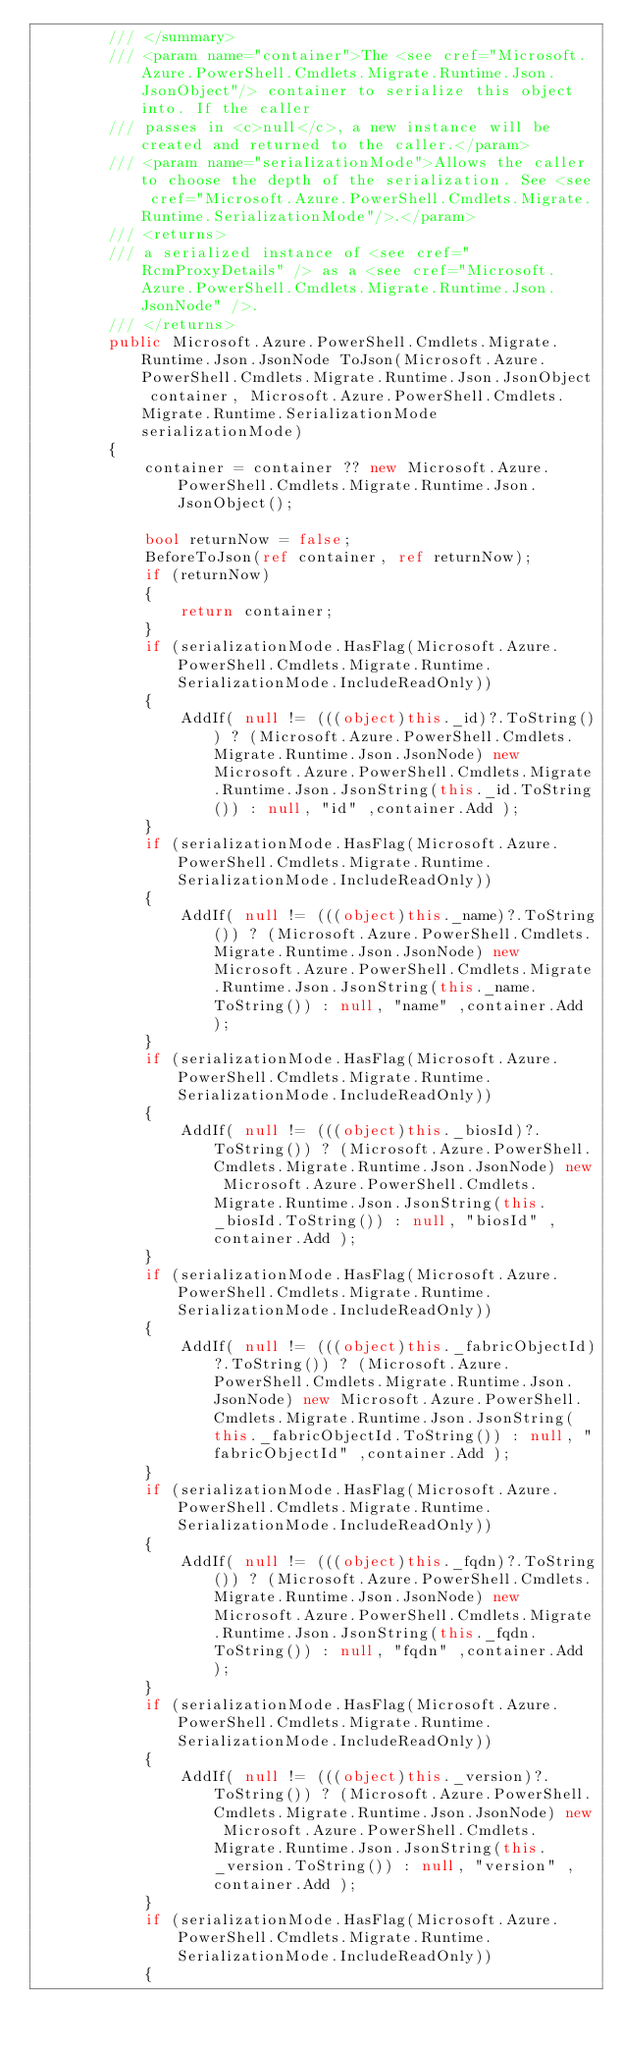<code> <loc_0><loc_0><loc_500><loc_500><_C#_>        /// </summary>
        /// <param name="container">The <see cref="Microsoft.Azure.PowerShell.Cmdlets.Migrate.Runtime.Json.JsonObject"/> container to serialize this object into. If the caller
        /// passes in <c>null</c>, a new instance will be created and returned to the caller.</param>
        /// <param name="serializationMode">Allows the caller to choose the depth of the serialization. See <see cref="Microsoft.Azure.PowerShell.Cmdlets.Migrate.Runtime.SerializationMode"/>.</param>
        /// <returns>
        /// a serialized instance of <see cref="RcmProxyDetails" /> as a <see cref="Microsoft.Azure.PowerShell.Cmdlets.Migrate.Runtime.Json.JsonNode" />.
        /// </returns>
        public Microsoft.Azure.PowerShell.Cmdlets.Migrate.Runtime.Json.JsonNode ToJson(Microsoft.Azure.PowerShell.Cmdlets.Migrate.Runtime.Json.JsonObject container, Microsoft.Azure.PowerShell.Cmdlets.Migrate.Runtime.SerializationMode serializationMode)
        {
            container = container ?? new Microsoft.Azure.PowerShell.Cmdlets.Migrate.Runtime.Json.JsonObject();

            bool returnNow = false;
            BeforeToJson(ref container, ref returnNow);
            if (returnNow)
            {
                return container;
            }
            if (serializationMode.HasFlag(Microsoft.Azure.PowerShell.Cmdlets.Migrate.Runtime.SerializationMode.IncludeReadOnly))
            {
                AddIf( null != (((object)this._id)?.ToString()) ? (Microsoft.Azure.PowerShell.Cmdlets.Migrate.Runtime.Json.JsonNode) new Microsoft.Azure.PowerShell.Cmdlets.Migrate.Runtime.Json.JsonString(this._id.ToString()) : null, "id" ,container.Add );
            }
            if (serializationMode.HasFlag(Microsoft.Azure.PowerShell.Cmdlets.Migrate.Runtime.SerializationMode.IncludeReadOnly))
            {
                AddIf( null != (((object)this._name)?.ToString()) ? (Microsoft.Azure.PowerShell.Cmdlets.Migrate.Runtime.Json.JsonNode) new Microsoft.Azure.PowerShell.Cmdlets.Migrate.Runtime.Json.JsonString(this._name.ToString()) : null, "name" ,container.Add );
            }
            if (serializationMode.HasFlag(Microsoft.Azure.PowerShell.Cmdlets.Migrate.Runtime.SerializationMode.IncludeReadOnly))
            {
                AddIf( null != (((object)this._biosId)?.ToString()) ? (Microsoft.Azure.PowerShell.Cmdlets.Migrate.Runtime.Json.JsonNode) new Microsoft.Azure.PowerShell.Cmdlets.Migrate.Runtime.Json.JsonString(this._biosId.ToString()) : null, "biosId" ,container.Add );
            }
            if (serializationMode.HasFlag(Microsoft.Azure.PowerShell.Cmdlets.Migrate.Runtime.SerializationMode.IncludeReadOnly))
            {
                AddIf( null != (((object)this._fabricObjectId)?.ToString()) ? (Microsoft.Azure.PowerShell.Cmdlets.Migrate.Runtime.Json.JsonNode) new Microsoft.Azure.PowerShell.Cmdlets.Migrate.Runtime.Json.JsonString(this._fabricObjectId.ToString()) : null, "fabricObjectId" ,container.Add );
            }
            if (serializationMode.HasFlag(Microsoft.Azure.PowerShell.Cmdlets.Migrate.Runtime.SerializationMode.IncludeReadOnly))
            {
                AddIf( null != (((object)this._fqdn)?.ToString()) ? (Microsoft.Azure.PowerShell.Cmdlets.Migrate.Runtime.Json.JsonNode) new Microsoft.Azure.PowerShell.Cmdlets.Migrate.Runtime.Json.JsonString(this._fqdn.ToString()) : null, "fqdn" ,container.Add );
            }
            if (serializationMode.HasFlag(Microsoft.Azure.PowerShell.Cmdlets.Migrate.Runtime.SerializationMode.IncludeReadOnly))
            {
                AddIf( null != (((object)this._version)?.ToString()) ? (Microsoft.Azure.PowerShell.Cmdlets.Migrate.Runtime.Json.JsonNode) new Microsoft.Azure.PowerShell.Cmdlets.Migrate.Runtime.Json.JsonString(this._version.ToString()) : null, "version" ,container.Add );
            }
            if (serializationMode.HasFlag(Microsoft.Azure.PowerShell.Cmdlets.Migrate.Runtime.SerializationMode.IncludeReadOnly))
            {</code> 